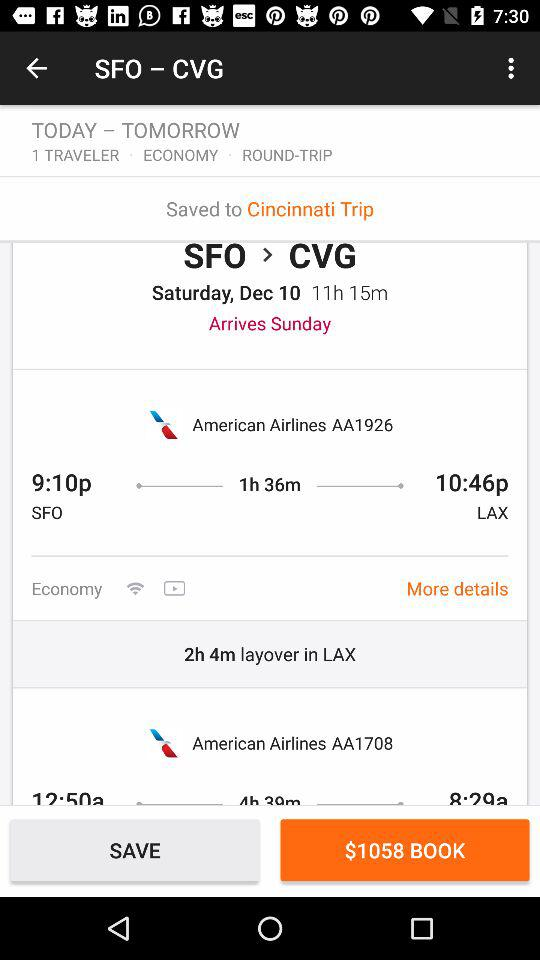When does the flight arrive in Covington?
When the provided information is insufficient, respond with <no answer>. <no answer> 